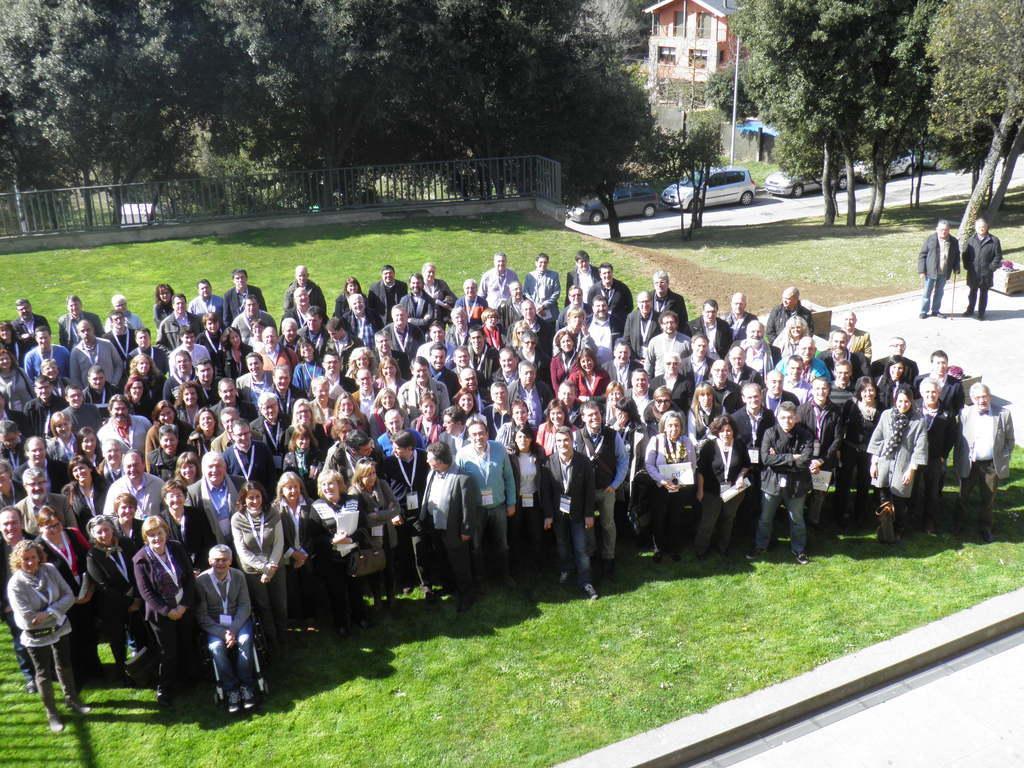How would you summarize this image in a sentence or two? In this image I can see number of persons are standing on the ground. I can see some grass on the ground, few vehicles on the road, the railing, few trees which are green in color and a building. 